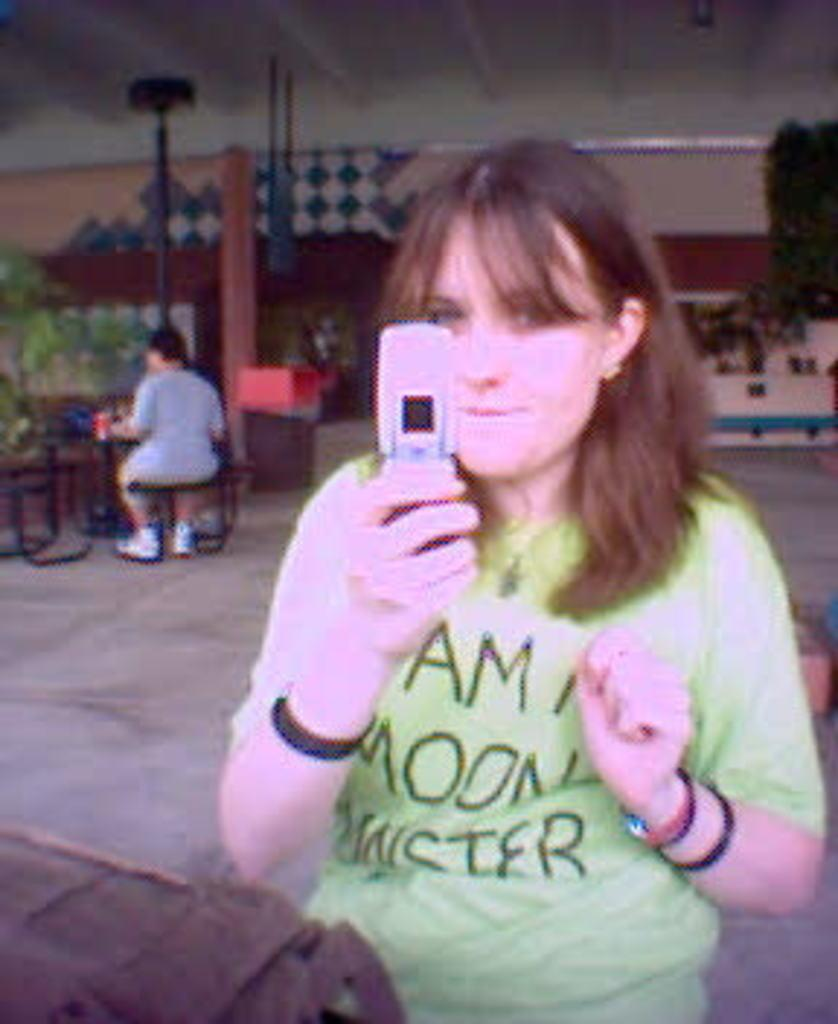What is the main object being held in the image? There is a mobile being held by someone in the image. Can you describe the person holding the mobile? Unfortunately, the image does not provide enough information to describe the person holding the mobile. What can be seen in the background of the image? In the background of the image, there are plants, a wall, a roof, and some unspecified objects. How many people are visible in the image? There is only one person visible in the image, the one holding the mobile. What type of operation is being performed on the wren in the image? There is no wren present in the image, and therefore no operation is being performed on it. 